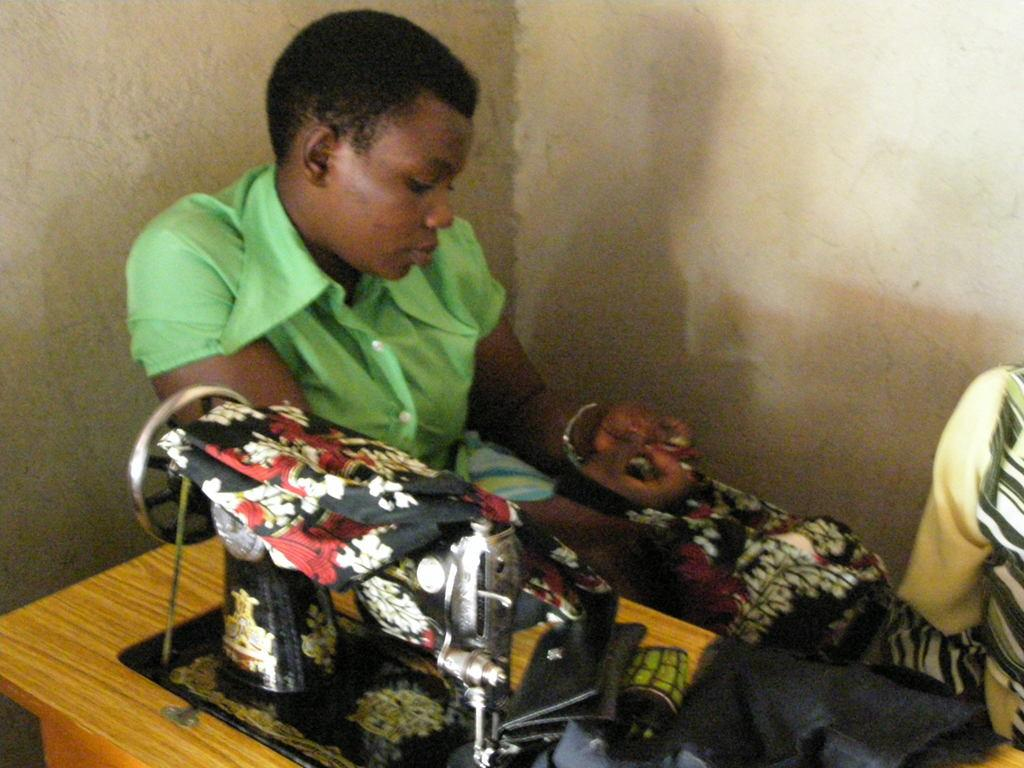What is the woman doing in the image? The woman is sitting at the table in the image. What object is on the table with the woman? There is a stitch machine on the table. What else is on the table besides the stitch machine? There are clothes on the table. What can be seen in the background of the image? There is a wall in the background of the image. What type of curve can be seen in the image? There is no curve present in the image. Can you describe the agreement between the woman and the stitch machine in the image? There is no agreement between the woman and the stitch machine in the image; it is an inanimate object. 